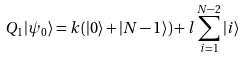<formula> <loc_0><loc_0><loc_500><loc_500>Q _ { 1 } | \psi _ { 0 } \rangle = k ( | 0 \rangle + | { N - 1 } \rangle ) + l \sum ^ { N - 2 } _ { i = 1 } | i \rangle</formula> 